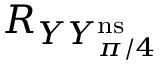Convert formula to latex. <formula><loc_0><loc_0><loc_500><loc_500>R _ { Y Y _ { \pi / 4 } ^ { n s } }</formula> 